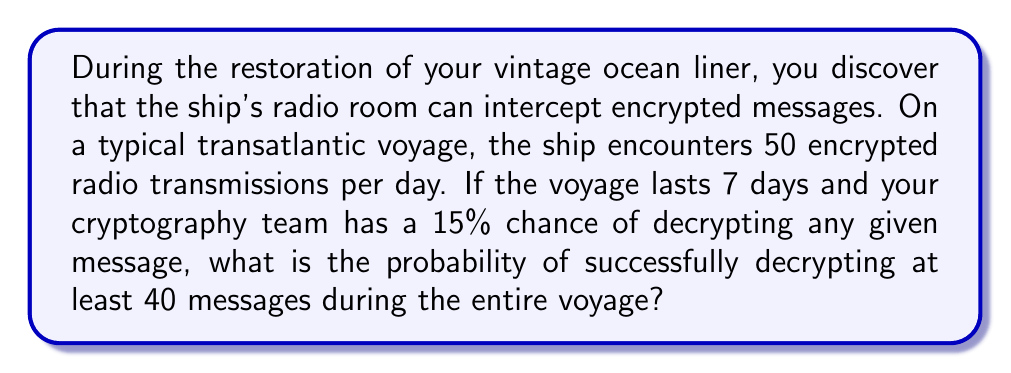Show me your answer to this math problem. Let's approach this step-by-step:

1) First, we need to calculate the total number of messages encountered during the voyage:
   $50$ messages/day $\times 7$ days $= 350$ total messages

2) We can model this scenario as a binomial distribution, where:
   $n = 350$ (total number of trials)
   $p = 0.15$ (probability of success for each trial)
   $X =$ number of successfully decrypted messages

3) We want to find $P(X \geq 40)$, which is equivalent to $1 - P(X < 40)$ or $1 - P(X \leq 39)$

4) The probability mass function for a binomial distribution is:

   $$P(X = k) = \binom{n}{k} p^k (1-p)^{n-k}$$

5) We need to sum this for all values from 0 to 39:

   $$P(X \leq 39) = \sum_{k=0}^{39} \binom{350}{k} (0.15)^k (0.85)^{350-k}$$

6) This sum is complex to calculate by hand, so we would typically use statistical software or a calculator with binomial probability functions.

7) Using such a tool, we find that $P(X \leq 39) \approx 0.0728$

8) Therefore, $P(X \geq 40) = 1 - P(X \leq 39) \approx 1 - 0.0728 = 0.9272$
Answer: $0.9272$ or $92.72\%$ 